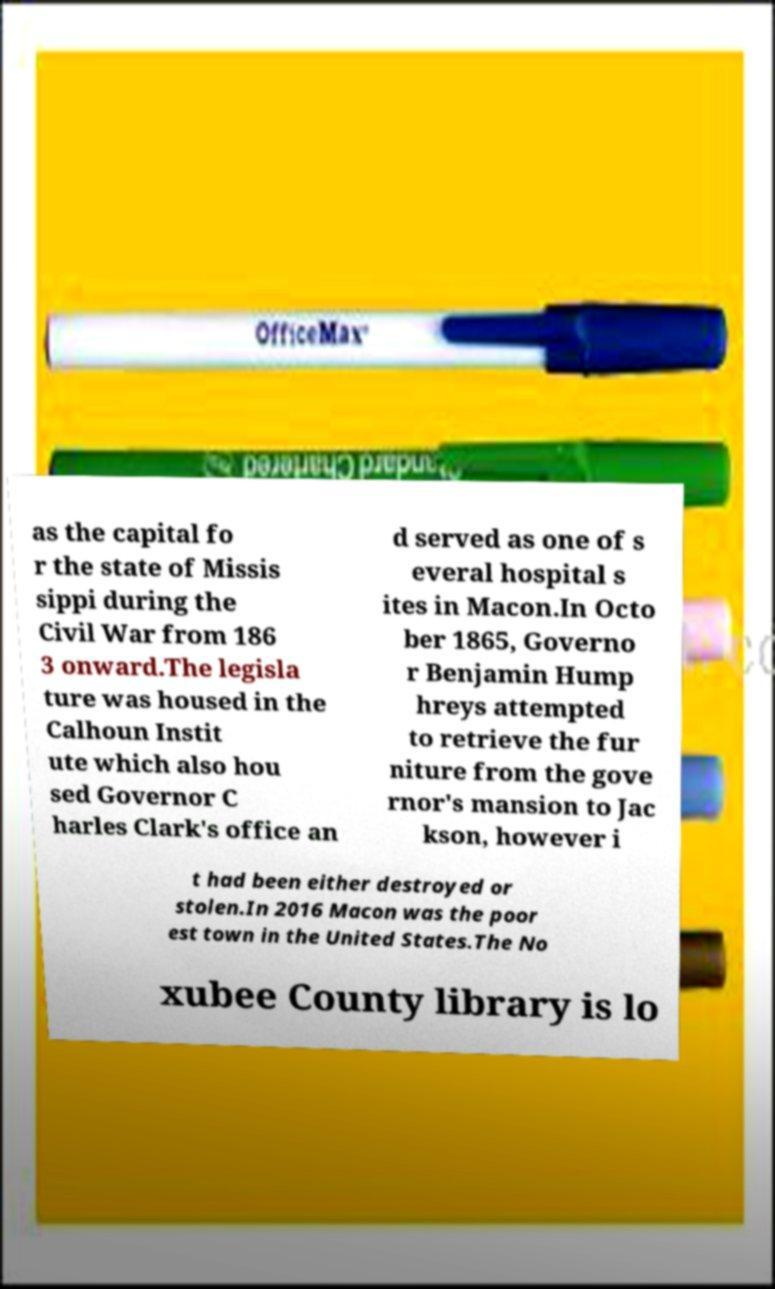For documentation purposes, I need the text within this image transcribed. Could you provide that? as the capital fo r the state of Missis sippi during the Civil War from 186 3 onward.The legisla ture was housed in the Calhoun Instit ute which also hou sed Governor C harles Clark's office an d served as one of s everal hospital s ites in Macon.In Octo ber 1865, Governo r Benjamin Hump hreys attempted to retrieve the fur niture from the gove rnor's mansion to Jac kson, however i t had been either destroyed or stolen.In 2016 Macon was the poor est town in the United States.The No xubee County library is lo 